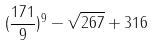<formula> <loc_0><loc_0><loc_500><loc_500>( \frac { 1 7 1 } { 9 } ) ^ { 9 } - \sqrt { 2 6 7 } + 3 1 6</formula> 